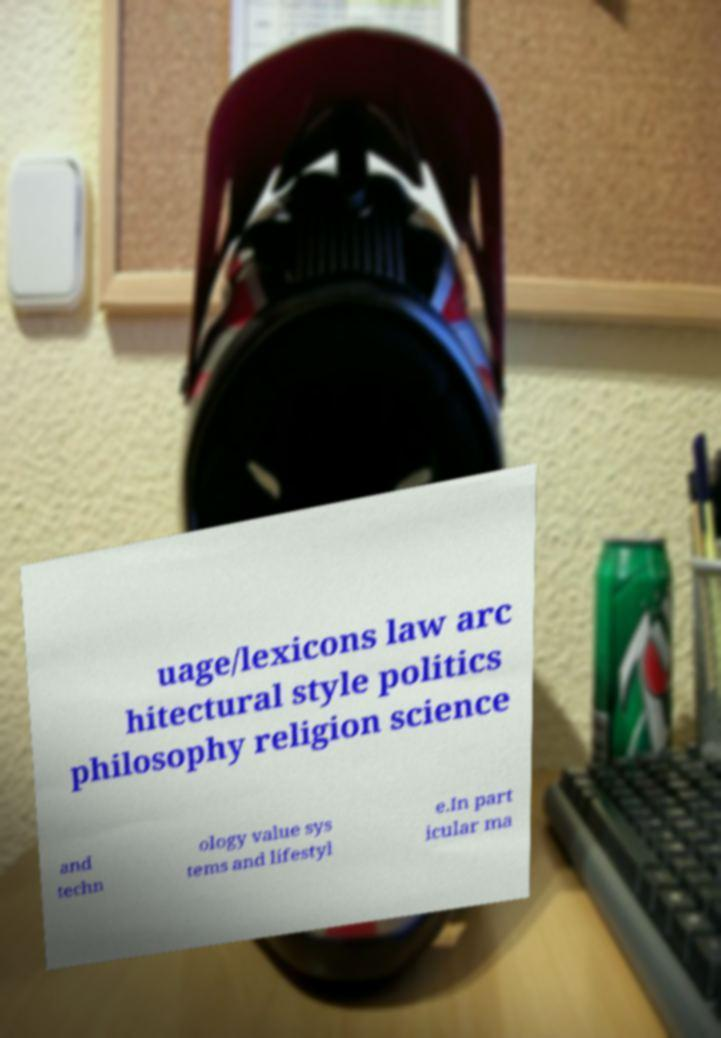Can you accurately transcribe the text from the provided image for me? uage/lexicons law arc hitectural style politics philosophy religion science and techn ology value sys tems and lifestyl e.In part icular ma 